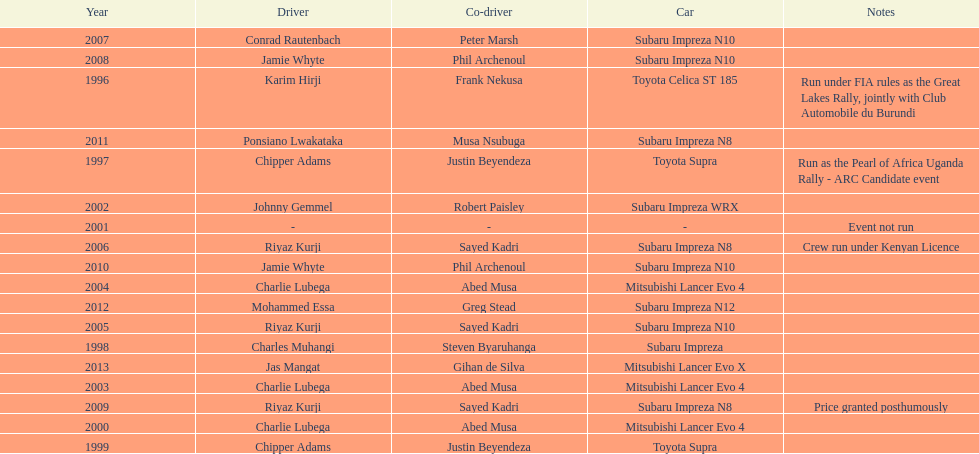Which was the only year that the event was not run? 2001. 